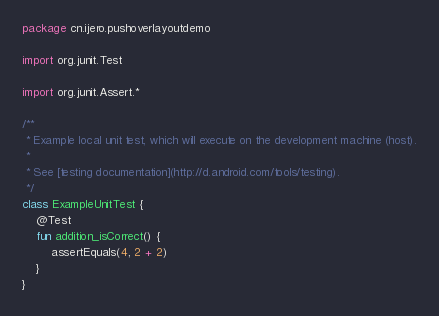Convert code to text. <code><loc_0><loc_0><loc_500><loc_500><_Kotlin_>package cn.ijero.pushoverlayoutdemo

import org.junit.Test

import org.junit.Assert.*

/**
 * Example local unit test, which will execute on the development machine (host).
 *
 * See [testing documentation](http://d.android.com/tools/testing).
 */
class ExampleUnitTest {
    @Test
    fun addition_isCorrect() {
        assertEquals(4, 2 + 2)
    }
}
</code> 